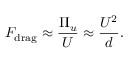<formula> <loc_0><loc_0><loc_500><loc_500>F _ { d r a g } \approx \frac { \Pi _ { u } } { U } \approx \frac { U ^ { 2 } } { d } .</formula> 